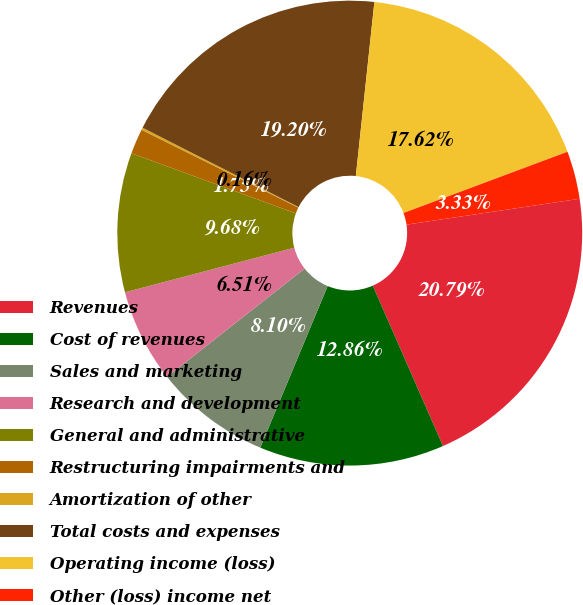Convert chart. <chart><loc_0><loc_0><loc_500><loc_500><pie_chart><fcel>Revenues<fcel>Cost of revenues<fcel>Sales and marketing<fcel>Research and development<fcel>General and administrative<fcel>Restructuring impairments and<fcel>Amortization of other<fcel>Total costs and expenses<fcel>Operating income (loss)<fcel>Other (loss) income net<nl><fcel>20.79%<fcel>12.86%<fcel>8.1%<fcel>6.51%<fcel>9.68%<fcel>1.75%<fcel>0.16%<fcel>19.2%<fcel>17.62%<fcel>3.33%<nl></chart> 